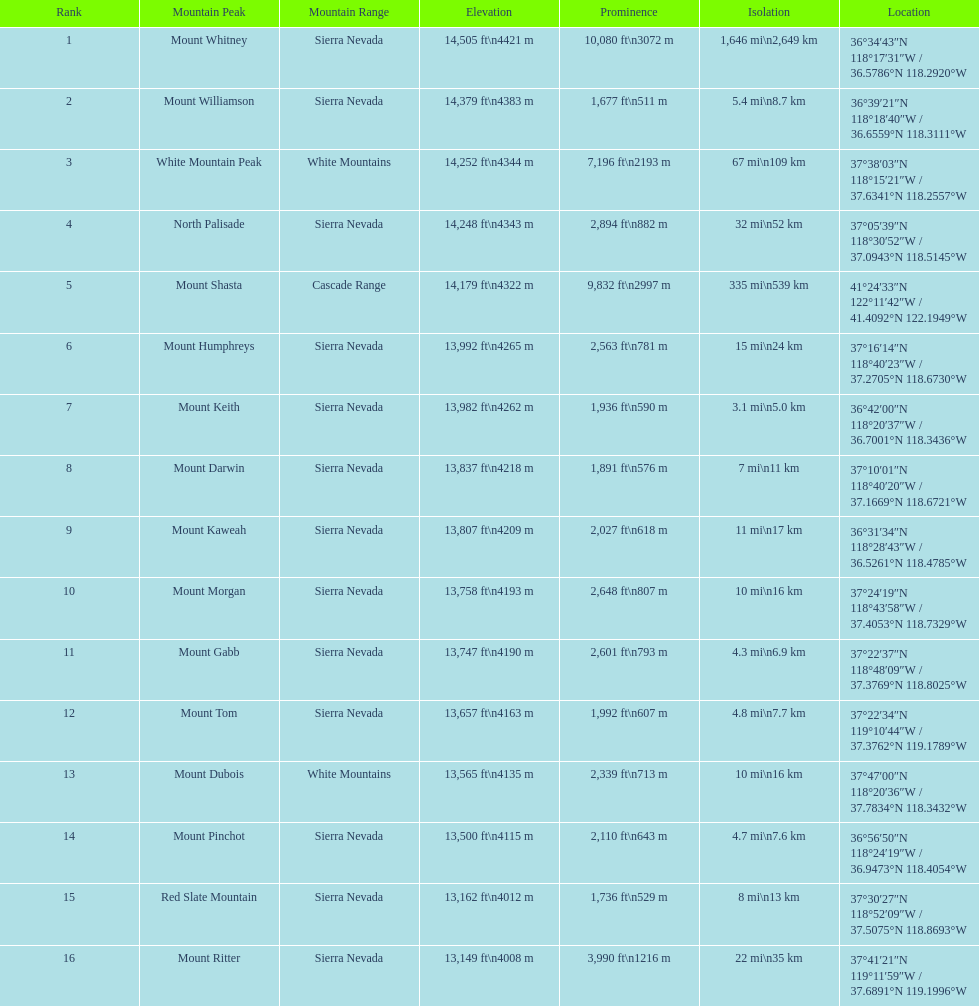How much higher is the mountain apex of mount williamson compared to mount keith's? 397 ft. 